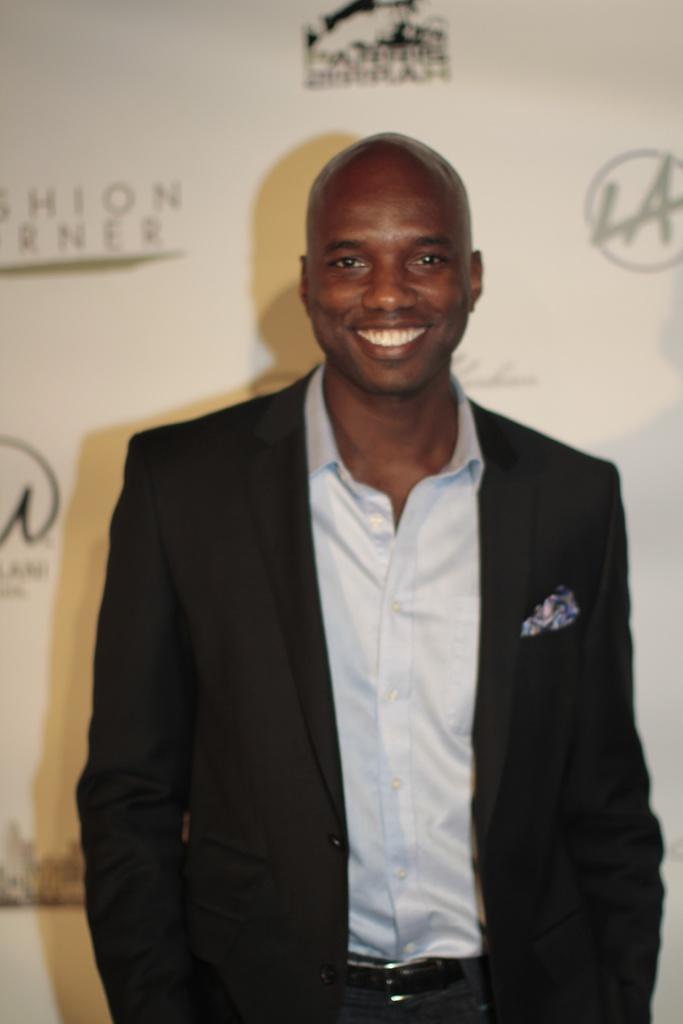In one or two sentences, can you explain what this image depicts? In this image there is a person standing with a smile on his face. In the background there is a banner with a sponsor names and logos. 